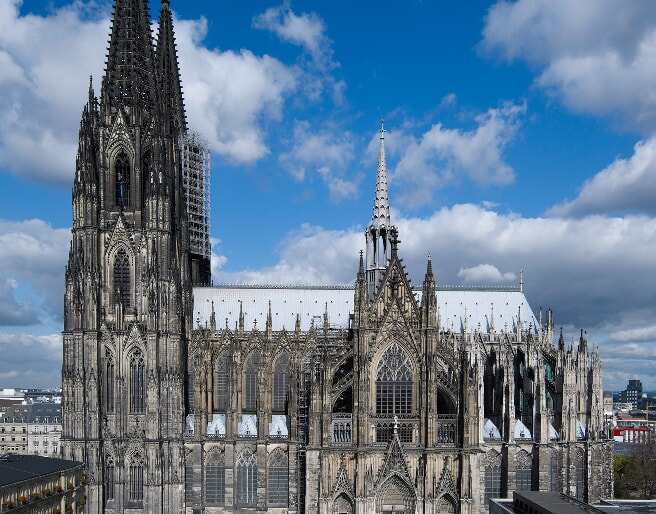Analyze the image in a comprehensive and detailed manner. The image beautifully captures the majestic Cologne Cathedral, a renowned Gothic landmark in Cologne, Germany. The cathedral, built from dark stone, stands in stark contrast to the clear blue sky above, which is dotted with fluffy white clouds. The photograph is taken from a high vantage point, providing a comprehensive view that highlights the cathedral's impressive architectural grandeur. The intricate details of the structure are clearly visible, featuring pointed arches, flying buttresses, and soaring spires that ambitiously reach towards the sky. In the distance, the surrounding buildings of Cologne provide an added layer of depth, contrasting with the cathedral's Gothic magnificence. The image not only emphasizes the cathedral's imposing presence but also showcases the meticulous craftsmanship involved in its construction. This snapshot is a testament to the timeless beauty and historical significance of the Cologne Cathedral. 